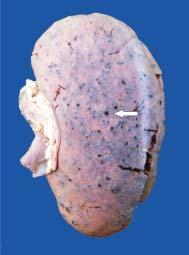does the cortex show tiny petechial haemorrhages visible through the capsule?
Answer the question using a single word or phrase. Yes 